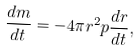<formula> <loc_0><loc_0><loc_500><loc_500>\frac { d m } { d t } = - 4 \pi r ^ { 2 } p \frac { d r } { d t } ,</formula> 